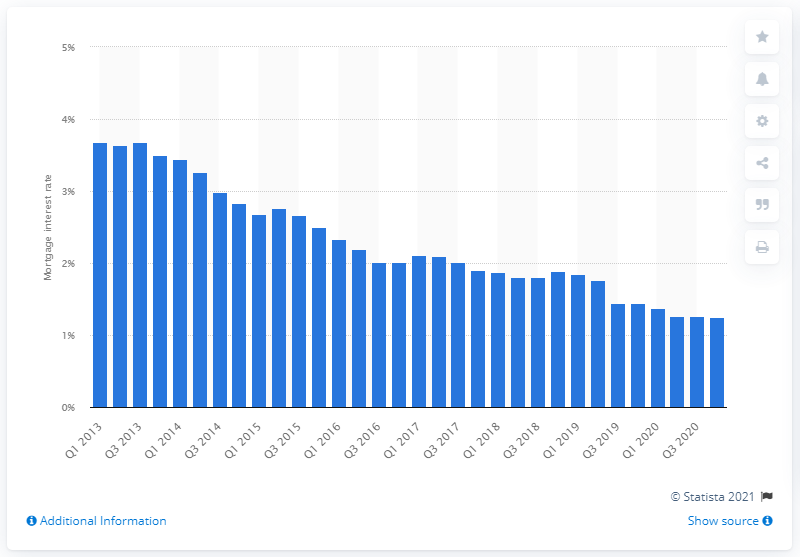Indicate a few pertinent items in this graphic. In the fourth quarter of 2020, the value of Italy's mortgage interest rates was 1.25%. The highest interest rate recorded in the first and third quarters of 2013 was 3.68%. 